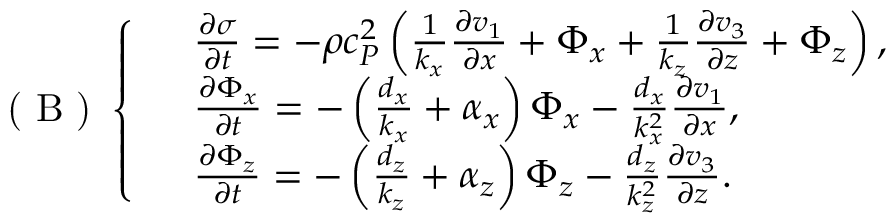<formula> <loc_0><loc_0><loc_500><loc_500>( B ) \left \{ \begin{array} { r l } & { \frac { \partial \sigma } { \partial t } = - \rho c _ { P } ^ { 2 } \left ( \frac { 1 } { k _ { x } } \frac { \partial v _ { 1 } } { \partial x } + \Phi _ { x } + \frac { 1 } { k _ { z } } \frac { \partial v _ { 3 } } { \partial z } + \Phi _ { z } \right ) , } \\ & { \frac { \partial \Phi _ { x } } { \partial t } = - \left ( \frac { d _ { x } } { k _ { x } } + \alpha _ { x } \right ) \Phi _ { x } - \frac { d _ { x } } { k _ { x } ^ { 2 } } \frac { \partial v _ { 1 } } { \partial x } , } \\ & { \frac { \partial \Phi _ { z } } { \partial t } = - \left ( \frac { d _ { z } } { k _ { z } } + \alpha _ { z } \right ) \Phi _ { z } - \frac { d _ { z } } { k _ { z } ^ { 2 } } \frac { \partial v _ { 3 } } { \partial z } . } \end{array}</formula> 